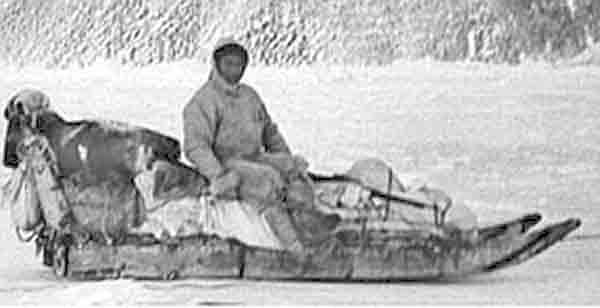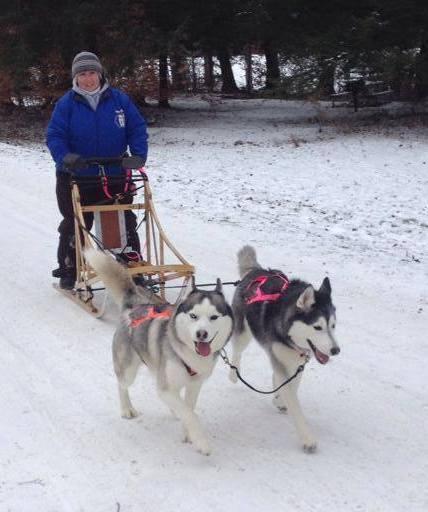The first image is the image on the left, the second image is the image on the right. Given the left and right images, does the statement "In at least one image there are at least two people being pulled by at least 6 sled dogs." hold true? Answer yes or no. No. The first image is the image on the left, the second image is the image on the right. For the images shown, is this caption "One of the people on the sleds is wearing a bright blue coat." true? Answer yes or no. Yes. 